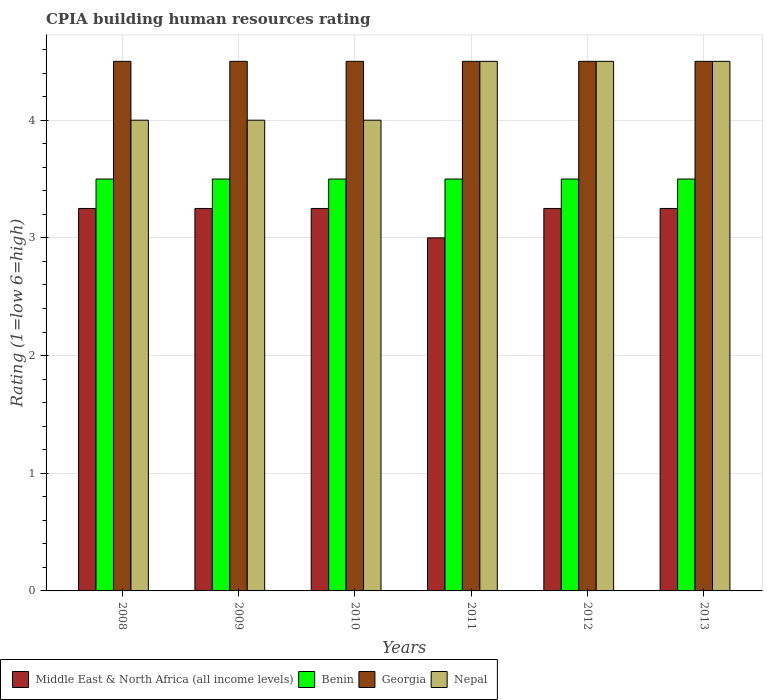How many different coloured bars are there?
Keep it short and to the point. 4. How many groups of bars are there?
Keep it short and to the point. 6. Are the number of bars per tick equal to the number of legend labels?
Your answer should be very brief. Yes. Are the number of bars on each tick of the X-axis equal?
Your response must be concise. Yes. What is the label of the 5th group of bars from the left?
Provide a succinct answer. 2012. What is the CPIA rating in Georgia in 2013?
Your response must be concise. 4.5. Across all years, what is the minimum CPIA rating in Georgia?
Offer a terse response. 4.5. What is the total CPIA rating in Middle East & North Africa (all income levels) in the graph?
Ensure brevity in your answer.  19.25. What is the difference between the CPIA rating in Nepal in 2008 and the CPIA rating in Georgia in 2011?
Provide a short and direct response. -0.5. What is the average CPIA rating in Nepal per year?
Make the answer very short. 4.25. In how many years, is the CPIA rating in Benin greater than 3?
Keep it short and to the point. 6. What is the difference between the highest and the second highest CPIA rating in Benin?
Your answer should be compact. 0. In how many years, is the CPIA rating in Georgia greater than the average CPIA rating in Georgia taken over all years?
Your answer should be compact. 0. Is the sum of the CPIA rating in Nepal in 2008 and 2011 greater than the maximum CPIA rating in Middle East & North Africa (all income levels) across all years?
Make the answer very short. Yes. What does the 4th bar from the left in 2012 represents?
Provide a short and direct response. Nepal. What does the 1st bar from the right in 2013 represents?
Offer a terse response. Nepal. Is it the case that in every year, the sum of the CPIA rating in Georgia and CPIA rating in Middle East & North Africa (all income levels) is greater than the CPIA rating in Benin?
Keep it short and to the point. Yes. Are all the bars in the graph horizontal?
Give a very brief answer. No. Does the graph contain any zero values?
Provide a succinct answer. No. How many legend labels are there?
Make the answer very short. 4. What is the title of the graph?
Keep it short and to the point. CPIA building human resources rating. Does "Finland" appear as one of the legend labels in the graph?
Give a very brief answer. No. What is the label or title of the X-axis?
Your response must be concise. Years. What is the Rating (1=low 6=high) in Middle East & North Africa (all income levels) in 2008?
Give a very brief answer. 3.25. What is the Rating (1=low 6=high) in Georgia in 2008?
Provide a short and direct response. 4.5. What is the Rating (1=low 6=high) of Georgia in 2009?
Offer a very short reply. 4.5. What is the Rating (1=low 6=high) of Benin in 2010?
Give a very brief answer. 3.5. What is the Rating (1=low 6=high) of Nepal in 2010?
Offer a very short reply. 4. What is the Rating (1=low 6=high) in Middle East & North Africa (all income levels) in 2011?
Your answer should be very brief. 3. What is the Rating (1=low 6=high) of Nepal in 2011?
Your answer should be compact. 4.5. What is the Rating (1=low 6=high) of Middle East & North Africa (all income levels) in 2012?
Give a very brief answer. 3.25. What is the Rating (1=low 6=high) in Benin in 2012?
Make the answer very short. 3.5. What is the Rating (1=low 6=high) of Nepal in 2012?
Make the answer very short. 4.5. What is the Rating (1=low 6=high) in Middle East & North Africa (all income levels) in 2013?
Your answer should be compact. 3.25. What is the Rating (1=low 6=high) in Benin in 2013?
Your answer should be very brief. 3.5. What is the Rating (1=low 6=high) in Nepal in 2013?
Give a very brief answer. 4.5. Across all years, what is the maximum Rating (1=low 6=high) of Nepal?
Your answer should be very brief. 4.5. Across all years, what is the minimum Rating (1=low 6=high) of Benin?
Make the answer very short. 3.5. Across all years, what is the minimum Rating (1=low 6=high) of Georgia?
Provide a short and direct response. 4.5. Across all years, what is the minimum Rating (1=low 6=high) in Nepal?
Your answer should be compact. 4. What is the total Rating (1=low 6=high) in Middle East & North Africa (all income levels) in the graph?
Keep it short and to the point. 19.25. What is the difference between the Rating (1=low 6=high) in Middle East & North Africa (all income levels) in 2008 and that in 2009?
Provide a short and direct response. 0. What is the difference between the Rating (1=low 6=high) of Benin in 2008 and that in 2009?
Your response must be concise. 0. What is the difference between the Rating (1=low 6=high) of Georgia in 2008 and that in 2009?
Provide a succinct answer. 0. What is the difference between the Rating (1=low 6=high) of Benin in 2008 and that in 2010?
Give a very brief answer. 0. What is the difference between the Rating (1=low 6=high) in Georgia in 2008 and that in 2010?
Give a very brief answer. 0. What is the difference between the Rating (1=low 6=high) in Nepal in 2008 and that in 2010?
Ensure brevity in your answer.  0. What is the difference between the Rating (1=low 6=high) of Benin in 2008 and that in 2011?
Ensure brevity in your answer.  0. What is the difference between the Rating (1=low 6=high) in Middle East & North Africa (all income levels) in 2008 and that in 2012?
Your response must be concise. 0. What is the difference between the Rating (1=low 6=high) of Nepal in 2008 and that in 2012?
Make the answer very short. -0.5. What is the difference between the Rating (1=low 6=high) in Middle East & North Africa (all income levels) in 2008 and that in 2013?
Offer a terse response. 0. What is the difference between the Rating (1=low 6=high) in Benin in 2008 and that in 2013?
Make the answer very short. 0. What is the difference between the Rating (1=low 6=high) in Georgia in 2008 and that in 2013?
Keep it short and to the point. 0. What is the difference between the Rating (1=low 6=high) of Nepal in 2008 and that in 2013?
Make the answer very short. -0.5. What is the difference between the Rating (1=low 6=high) in Middle East & North Africa (all income levels) in 2009 and that in 2010?
Give a very brief answer. 0. What is the difference between the Rating (1=low 6=high) in Georgia in 2009 and that in 2010?
Offer a terse response. 0. What is the difference between the Rating (1=low 6=high) in Middle East & North Africa (all income levels) in 2009 and that in 2011?
Your response must be concise. 0.25. What is the difference between the Rating (1=low 6=high) of Benin in 2009 and that in 2011?
Make the answer very short. 0. What is the difference between the Rating (1=low 6=high) of Georgia in 2009 and that in 2011?
Your response must be concise. 0. What is the difference between the Rating (1=low 6=high) in Georgia in 2009 and that in 2012?
Offer a very short reply. 0. What is the difference between the Rating (1=low 6=high) in Nepal in 2009 and that in 2012?
Provide a short and direct response. -0.5. What is the difference between the Rating (1=low 6=high) of Middle East & North Africa (all income levels) in 2009 and that in 2013?
Make the answer very short. 0. What is the difference between the Rating (1=low 6=high) of Benin in 2010 and that in 2013?
Give a very brief answer. 0. What is the difference between the Rating (1=low 6=high) of Middle East & North Africa (all income levels) in 2011 and that in 2012?
Keep it short and to the point. -0.25. What is the difference between the Rating (1=low 6=high) of Benin in 2011 and that in 2012?
Your response must be concise. 0. What is the difference between the Rating (1=low 6=high) of Georgia in 2011 and that in 2012?
Offer a very short reply. 0. What is the difference between the Rating (1=low 6=high) of Nepal in 2011 and that in 2012?
Provide a succinct answer. 0. What is the difference between the Rating (1=low 6=high) in Benin in 2011 and that in 2013?
Give a very brief answer. 0. What is the difference between the Rating (1=low 6=high) of Benin in 2012 and that in 2013?
Your answer should be very brief. 0. What is the difference between the Rating (1=low 6=high) in Georgia in 2012 and that in 2013?
Ensure brevity in your answer.  0. What is the difference between the Rating (1=low 6=high) of Middle East & North Africa (all income levels) in 2008 and the Rating (1=low 6=high) of Georgia in 2009?
Provide a succinct answer. -1.25. What is the difference between the Rating (1=low 6=high) in Middle East & North Africa (all income levels) in 2008 and the Rating (1=low 6=high) in Nepal in 2009?
Make the answer very short. -0.75. What is the difference between the Rating (1=low 6=high) of Benin in 2008 and the Rating (1=low 6=high) of Georgia in 2009?
Ensure brevity in your answer.  -1. What is the difference between the Rating (1=low 6=high) of Georgia in 2008 and the Rating (1=low 6=high) of Nepal in 2009?
Keep it short and to the point. 0.5. What is the difference between the Rating (1=low 6=high) of Middle East & North Africa (all income levels) in 2008 and the Rating (1=low 6=high) of Benin in 2010?
Give a very brief answer. -0.25. What is the difference between the Rating (1=low 6=high) of Middle East & North Africa (all income levels) in 2008 and the Rating (1=low 6=high) of Georgia in 2010?
Your response must be concise. -1.25. What is the difference between the Rating (1=low 6=high) in Middle East & North Africa (all income levels) in 2008 and the Rating (1=low 6=high) in Nepal in 2010?
Give a very brief answer. -0.75. What is the difference between the Rating (1=low 6=high) of Benin in 2008 and the Rating (1=low 6=high) of Nepal in 2010?
Provide a succinct answer. -0.5. What is the difference between the Rating (1=low 6=high) of Georgia in 2008 and the Rating (1=low 6=high) of Nepal in 2010?
Give a very brief answer. 0.5. What is the difference between the Rating (1=low 6=high) in Middle East & North Africa (all income levels) in 2008 and the Rating (1=low 6=high) in Benin in 2011?
Offer a very short reply. -0.25. What is the difference between the Rating (1=low 6=high) in Middle East & North Africa (all income levels) in 2008 and the Rating (1=low 6=high) in Georgia in 2011?
Give a very brief answer. -1.25. What is the difference between the Rating (1=low 6=high) of Middle East & North Africa (all income levels) in 2008 and the Rating (1=low 6=high) of Nepal in 2011?
Give a very brief answer. -1.25. What is the difference between the Rating (1=low 6=high) of Benin in 2008 and the Rating (1=low 6=high) of Nepal in 2011?
Give a very brief answer. -1. What is the difference between the Rating (1=low 6=high) of Middle East & North Africa (all income levels) in 2008 and the Rating (1=low 6=high) of Benin in 2012?
Offer a very short reply. -0.25. What is the difference between the Rating (1=low 6=high) in Middle East & North Africa (all income levels) in 2008 and the Rating (1=low 6=high) in Georgia in 2012?
Provide a succinct answer. -1.25. What is the difference between the Rating (1=low 6=high) in Middle East & North Africa (all income levels) in 2008 and the Rating (1=low 6=high) in Nepal in 2012?
Keep it short and to the point. -1.25. What is the difference between the Rating (1=low 6=high) in Benin in 2008 and the Rating (1=low 6=high) in Georgia in 2012?
Your answer should be very brief. -1. What is the difference between the Rating (1=low 6=high) of Benin in 2008 and the Rating (1=low 6=high) of Nepal in 2012?
Your response must be concise. -1. What is the difference between the Rating (1=low 6=high) of Middle East & North Africa (all income levels) in 2008 and the Rating (1=low 6=high) of Georgia in 2013?
Give a very brief answer. -1.25. What is the difference between the Rating (1=low 6=high) of Middle East & North Africa (all income levels) in 2008 and the Rating (1=low 6=high) of Nepal in 2013?
Ensure brevity in your answer.  -1.25. What is the difference between the Rating (1=low 6=high) of Middle East & North Africa (all income levels) in 2009 and the Rating (1=low 6=high) of Georgia in 2010?
Your answer should be very brief. -1.25. What is the difference between the Rating (1=low 6=high) of Middle East & North Africa (all income levels) in 2009 and the Rating (1=low 6=high) of Nepal in 2010?
Make the answer very short. -0.75. What is the difference between the Rating (1=low 6=high) of Middle East & North Africa (all income levels) in 2009 and the Rating (1=low 6=high) of Benin in 2011?
Your answer should be compact. -0.25. What is the difference between the Rating (1=low 6=high) of Middle East & North Africa (all income levels) in 2009 and the Rating (1=low 6=high) of Georgia in 2011?
Provide a short and direct response. -1.25. What is the difference between the Rating (1=low 6=high) in Middle East & North Africa (all income levels) in 2009 and the Rating (1=low 6=high) in Nepal in 2011?
Offer a very short reply. -1.25. What is the difference between the Rating (1=low 6=high) of Benin in 2009 and the Rating (1=low 6=high) of Georgia in 2011?
Your response must be concise. -1. What is the difference between the Rating (1=low 6=high) in Georgia in 2009 and the Rating (1=low 6=high) in Nepal in 2011?
Your response must be concise. 0. What is the difference between the Rating (1=low 6=high) of Middle East & North Africa (all income levels) in 2009 and the Rating (1=low 6=high) of Benin in 2012?
Give a very brief answer. -0.25. What is the difference between the Rating (1=low 6=high) in Middle East & North Africa (all income levels) in 2009 and the Rating (1=low 6=high) in Georgia in 2012?
Your answer should be very brief. -1.25. What is the difference between the Rating (1=low 6=high) of Middle East & North Africa (all income levels) in 2009 and the Rating (1=low 6=high) of Nepal in 2012?
Your response must be concise. -1.25. What is the difference between the Rating (1=low 6=high) of Benin in 2009 and the Rating (1=low 6=high) of Georgia in 2012?
Make the answer very short. -1. What is the difference between the Rating (1=low 6=high) of Middle East & North Africa (all income levels) in 2009 and the Rating (1=low 6=high) of Benin in 2013?
Provide a succinct answer. -0.25. What is the difference between the Rating (1=low 6=high) in Middle East & North Africa (all income levels) in 2009 and the Rating (1=low 6=high) in Georgia in 2013?
Offer a terse response. -1.25. What is the difference between the Rating (1=low 6=high) in Middle East & North Africa (all income levels) in 2009 and the Rating (1=low 6=high) in Nepal in 2013?
Offer a terse response. -1.25. What is the difference between the Rating (1=low 6=high) of Benin in 2009 and the Rating (1=low 6=high) of Georgia in 2013?
Ensure brevity in your answer.  -1. What is the difference between the Rating (1=low 6=high) in Benin in 2009 and the Rating (1=low 6=high) in Nepal in 2013?
Offer a very short reply. -1. What is the difference between the Rating (1=low 6=high) of Middle East & North Africa (all income levels) in 2010 and the Rating (1=low 6=high) of Benin in 2011?
Offer a terse response. -0.25. What is the difference between the Rating (1=low 6=high) in Middle East & North Africa (all income levels) in 2010 and the Rating (1=low 6=high) in Georgia in 2011?
Make the answer very short. -1.25. What is the difference between the Rating (1=low 6=high) in Middle East & North Africa (all income levels) in 2010 and the Rating (1=low 6=high) in Nepal in 2011?
Keep it short and to the point. -1.25. What is the difference between the Rating (1=low 6=high) in Benin in 2010 and the Rating (1=low 6=high) in Georgia in 2011?
Offer a very short reply. -1. What is the difference between the Rating (1=low 6=high) in Benin in 2010 and the Rating (1=low 6=high) in Nepal in 2011?
Make the answer very short. -1. What is the difference between the Rating (1=low 6=high) of Georgia in 2010 and the Rating (1=low 6=high) of Nepal in 2011?
Provide a short and direct response. 0. What is the difference between the Rating (1=low 6=high) in Middle East & North Africa (all income levels) in 2010 and the Rating (1=low 6=high) in Benin in 2012?
Your response must be concise. -0.25. What is the difference between the Rating (1=low 6=high) in Middle East & North Africa (all income levels) in 2010 and the Rating (1=low 6=high) in Georgia in 2012?
Give a very brief answer. -1.25. What is the difference between the Rating (1=low 6=high) in Middle East & North Africa (all income levels) in 2010 and the Rating (1=low 6=high) in Nepal in 2012?
Keep it short and to the point. -1.25. What is the difference between the Rating (1=low 6=high) in Benin in 2010 and the Rating (1=low 6=high) in Georgia in 2012?
Keep it short and to the point. -1. What is the difference between the Rating (1=low 6=high) of Middle East & North Africa (all income levels) in 2010 and the Rating (1=low 6=high) of Georgia in 2013?
Your answer should be compact. -1.25. What is the difference between the Rating (1=low 6=high) of Middle East & North Africa (all income levels) in 2010 and the Rating (1=low 6=high) of Nepal in 2013?
Give a very brief answer. -1.25. What is the difference between the Rating (1=low 6=high) in Benin in 2010 and the Rating (1=low 6=high) in Georgia in 2013?
Your response must be concise. -1. What is the difference between the Rating (1=low 6=high) in Benin in 2010 and the Rating (1=low 6=high) in Nepal in 2013?
Offer a terse response. -1. What is the difference between the Rating (1=low 6=high) in Georgia in 2010 and the Rating (1=low 6=high) in Nepal in 2013?
Your answer should be compact. 0. What is the difference between the Rating (1=low 6=high) of Benin in 2011 and the Rating (1=low 6=high) of Georgia in 2012?
Keep it short and to the point. -1. What is the difference between the Rating (1=low 6=high) of Benin in 2011 and the Rating (1=low 6=high) of Nepal in 2012?
Make the answer very short. -1. What is the difference between the Rating (1=low 6=high) of Benin in 2011 and the Rating (1=low 6=high) of Georgia in 2013?
Make the answer very short. -1. What is the difference between the Rating (1=low 6=high) of Middle East & North Africa (all income levels) in 2012 and the Rating (1=low 6=high) of Benin in 2013?
Ensure brevity in your answer.  -0.25. What is the difference between the Rating (1=low 6=high) in Middle East & North Africa (all income levels) in 2012 and the Rating (1=low 6=high) in Georgia in 2013?
Make the answer very short. -1.25. What is the difference between the Rating (1=low 6=high) in Middle East & North Africa (all income levels) in 2012 and the Rating (1=low 6=high) in Nepal in 2013?
Offer a terse response. -1.25. What is the difference between the Rating (1=low 6=high) in Benin in 2012 and the Rating (1=low 6=high) in Georgia in 2013?
Offer a very short reply. -1. What is the difference between the Rating (1=low 6=high) of Georgia in 2012 and the Rating (1=low 6=high) of Nepal in 2013?
Your answer should be very brief. 0. What is the average Rating (1=low 6=high) in Middle East & North Africa (all income levels) per year?
Your answer should be compact. 3.21. What is the average Rating (1=low 6=high) of Georgia per year?
Your answer should be very brief. 4.5. What is the average Rating (1=low 6=high) in Nepal per year?
Ensure brevity in your answer.  4.25. In the year 2008, what is the difference between the Rating (1=low 6=high) in Middle East & North Africa (all income levels) and Rating (1=low 6=high) in Benin?
Provide a short and direct response. -0.25. In the year 2008, what is the difference between the Rating (1=low 6=high) in Middle East & North Africa (all income levels) and Rating (1=low 6=high) in Georgia?
Offer a terse response. -1.25. In the year 2008, what is the difference between the Rating (1=low 6=high) in Middle East & North Africa (all income levels) and Rating (1=low 6=high) in Nepal?
Make the answer very short. -0.75. In the year 2008, what is the difference between the Rating (1=low 6=high) of Benin and Rating (1=low 6=high) of Georgia?
Keep it short and to the point. -1. In the year 2008, what is the difference between the Rating (1=low 6=high) in Benin and Rating (1=low 6=high) in Nepal?
Keep it short and to the point. -0.5. In the year 2008, what is the difference between the Rating (1=low 6=high) of Georgia and Rating (1=low 6=high) of Nepal?
Ensure brevity in your answer.  0.5. In the year 2009, what is the difference between the Rating (1=low 6=high) in Middle East & North Africa (all income levels) and Rating (1=low 6=high) in Georgia?
Give a very brief answer. -1.25. In the year 2009, what is the difference between the Rating (1=low 6=high) of Middle East & North Africa (all income levels) and Rating (1=low 6=high) of Nepal?
Offer a very short reply. -0.75. In the year 2009, what is the difference between the Rating (1=low 6=high) in Benin and Rating (1=low 6=high) in Georgia?
Ensure brevity in your answer.  -1. In the year 2009, what is the difference between the Rating (1=low 6=high) in Benin and Rating (1=low 6=high) in Nepal?
Your answer should be very brief. -0.5. In the year 2009, what is the difference between the Rating (1=low 6=high) of Georgia and Rating (1=low 6=high) of Nepal?
Provide a short and direct response. 0.5. In the year 2010, what is the difference between the Rating (1=low 6=high) in Middle East & North Africa (all income levels) and Rating (1=low 6=high) in Benin?
Provide a succinct answer. -0.25. In the year 2010, what is the difference between the Rating (1=low 6=high) of Middle East & North Africa (all income levels) and Rating (1=low 6=high) of Georgia?
Provide a succinct answer. -1.25. In the year 2010, what is the difference between the Rating (1=low 6=high) in Middle East & North Africa (all income levels) and Rating (1=low 6=high) in Nepal?
Offer a terse response. -0.75. In the year 2010, what is the difference between the Rating (1=low 6=high) in Georgia and Rating (1=low 6=high) in Nepal?
Your answer should be compact. 0.5. In the year 2011, what is the difference between the Rating (1=low 6=high) in Benin and Rating (1=low 6=high) in Georgia?
Provide a succinct answer. -1. In the year 2011, what is the difference between the Rating (1=low 6=high) in Georgia and Rating (1=low 6=high) in Nepal?
Ensure brevity in your answer.  0. In the year 2012, what is the difference between the Rating (1=low 6=high) of Middle East & North Africa (all income levels) and Rating (1=low 6=high) of Benin?
Provide a short and direct response. -0.25. In the year 2012, what is the difference between the Rating (1=low 6=high) in Middle East & North Africa (all income levels) and Rating (1=low 6=high) in Georgia?
Your response must be concise. -1.25. In the year 2012, what is the difference between the Rating (1=low 6=high) of Middle East & North Africa (all income levels) and Rating (1=low 6=high) of Nepal?
Your answer should be compact. -1.25. In the year 2012, what is the difference between the Rating (1=low 6=high) in Benin and Rating (1=low 6=high) in Nepal?
Your answer should be compact. -1. In the year 2012, what is the difference between the Rating (1=low 6=high) of Georgia and Rating (1=low 6=high) of Nepal?
Your answer should be very brief. 0. In the year 2013, what is the difference between the Rating (1=low 6=high) of Middle East & North Africa (all income levels) and Rating (1=low 6=high) of Georgia?
Make the answer very short. -1.25. In the year 2013, what is the difference between the Rating (1=low 6=high) of Middle East & North Africa (all income levels) and Rating (1=low 6=high) of Nepal?
Offer a very short reply. -1.25. In the year 2013, what is the difference between the Rating (1=low 6=high) of Benin and Rating (1=low 6=high) of Nepal?
Your answer should be very brief. -1. In the year 2013, what is the difference between the Rating (1=low 6=high) in Georgia and Rating (1=low 6=high) in Nepal?
Provide a succinct answer. 0. What is the ratio of the Rating (1=low 6=high) of Middle East & North Africa (all income levels) in 2008 to that in 2009?
Offer a terse response. 1. What is the ratio of the Rating (1=low 6=high) of Benin in 2008 to that in 2009?
Provide a short and direct response. 1. What is the ratio of the Rating (1=low 6=high) of Nepal in 2008 to that in 2009?
Your answer should be compact. 1. What is the ratio of the Rating (1=low 6=high) in Nepal in 2008 to that in 2010?
Ensure brevity in your answer.  1. What is the ratio of the Rating (1=low 6=high) in Middle East & North Africa (all income levels) in 2008 to that in 2011?
Give a very brief answer. 1.08. What is the ratio of the Rating (1=low 6=high) in Benin in 2008 to that in 2011?
Your answer should be very brief. 1. What is the ratio of the Rating (1=low 6=high) in Georgia in 2008 to that in 2011?
Your answer should be compact. 1. What is the ratio of the Rating (1=low 6=high) of Georgia in 2008 to that in 2012?
Ensure brevity in your answer.  1. What is the ratio of the Rating (1=low 6=high) in Nepal in 2008 to that in 2012?
Make the answer very short. 0.89. What is the ratio of the Rating (1=low 6=high) in Georgia in 2008 to that in 2013?
Make the answer very short. 1. What is the ratio of the Rating (1=low 6=high) in Benin in 2009 to that in 2010?
Give a very brief answer. 1. What is the ratio of the Rating (1=low 6=high) in Georgia in 2009 to that in 2010?
Provide a succinct answer. 1. What is the ratio of the Rating (1=low 6=high) of Georgia in 2009 to that in 2011?
Provide a short and direct response. 1. What is the ratio of the Rating (1=low 6=high) of Nepal in 2009 to that in 2012?
Make the answer very short. 0.89. What is the ratio of the Rating (1=low 6=high) in Benin in 2009 to that in 2013?
Keep it short and to the point. 1. What is the ratio of the Rating (1=low 6=high) of Georgia in 2009 to that in 2013?
Offer a very short reply. 1. What is the ratio of the Rating (1=low 6=high) of Nepal in 2010 to that in 2011?
Provide a succinct answer. 0.89. What is the ratio of the Rating (1=low 6=high) of Nepal in 2010 to that in 2012?
Your answer should be compact. 0.89. What is the ratio of the Rating (1=low 6=high) in Middle East & North Africa (all income levels) in 2010 to that in 2013?
Your answer should be compact. 1. What is the ratio of the Rating (1=low 6=high) in Nepal in 2010 to that in 2013?
Make the answer very short. 0.89. What is the ratio of the Rating (1=low 6=high) in Middle East & North Africa (all income levels) in 2011 to that in 2013?
Your response must be concise. 0.92. What is the ratio of the Rating (1=low 6=high) in Benin in 2011 to that in 2013?
Offer a terse response. 1. What is the ratio of the Rating (1=low 6=high) in Nepal in 2011 to that in 2013?
Provide a succinct answer. 1. What is the ratio of the Rating (1=low 6=high) in Middle East & North Africa (all income levels) in 2012 to that in 2013?
Offer a very short reply. 1. What is the ratio of the Rating (1=low 6=high) of Georgia in 2012 to that in 2013?
Provide a succinct answer. 1. What is the difference between the highest and the second highest Rating (1=low 6=high) in Benin?
Keep it short and to the point. 0. What is the difference between the highest and the second highest Rating (1=low 6=high) in Georgia?
Give a very brief answer. 0. What is the difference between the highest and the second highest Rating (1=low 6=high) of Nepal?
Provide a succinct answer. 0. What is the difference between the highest and the lowest Rating (1=low 6=high) in Middle East & North Africa (all income levels)?
Make the answer very short. 0.25. What is the difference between the highest and the lowest Rating (1=low 6=high) in Benin?
Offer a terse response. 0. What is the difference between the highest and the lowest Rating (1=low 6=high) in Georgia?
Ensure brevity in your answer.  0. 